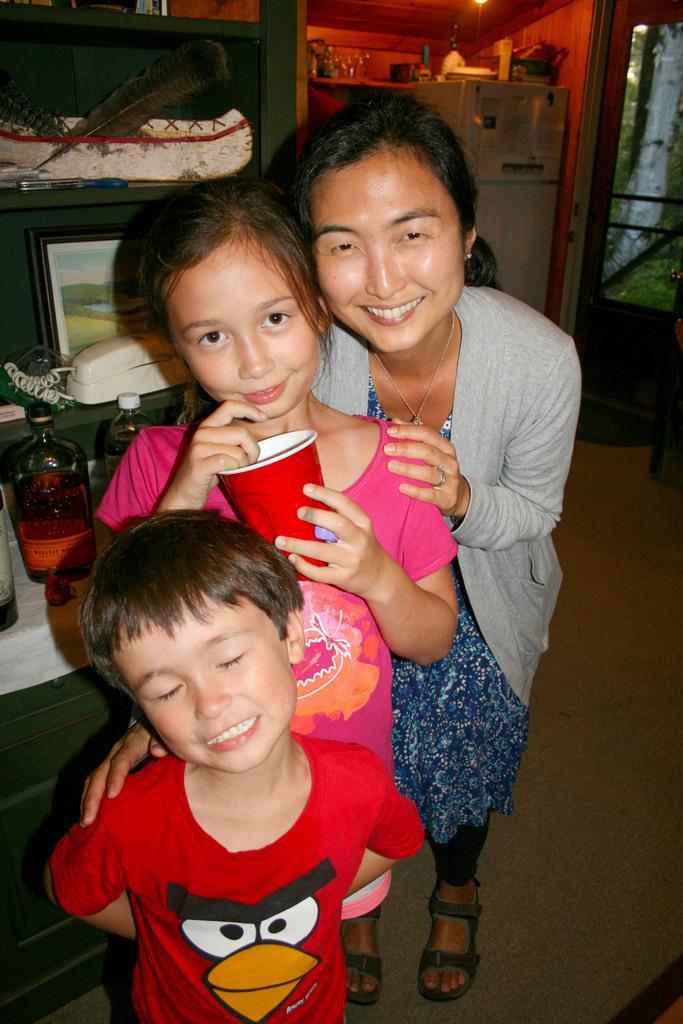Can you describe this image briefly? In the background we can see a door and objects on the refrigerator. Here we can see people standing and smiling. Here we can see a girl is holding a red glass. Behind to the them we can see telephone, frame, bottles and other objects. At the top we can see a light. 